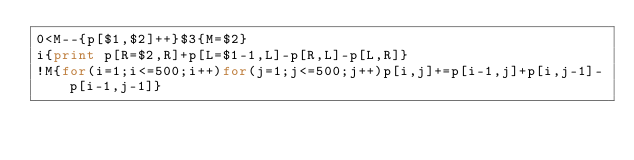<code> <loc_0><loc_0><loc_500><loc_500><_Awk_>0<M--{p[$1,$2]++}$3{M=$2}
i{print p[R=$2,R]+p[L=$1-1,L]-p[R,L]-p[L,R]}
!M{for(i=1;i<=500;i++)for(j=1;j<=500;j++)p[i,j]+=p[i-1,j]+p[i,j-1]-p[i-1,j-1]}</code> 